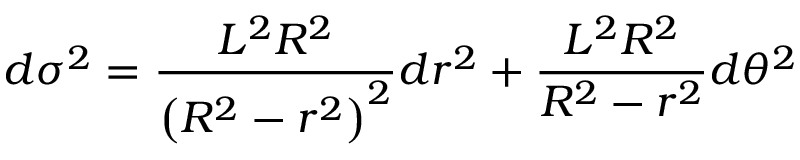<formula> <loc_0><loc_0><loc_500><loc_500>d \sigma ^ { 2 } = \frac { L ^ { 2 } R ^ { 2 } } { \left ( R ^ { 2 } - r ^ { 2 } \right ) ^ { 2 } } d r ^ { 2 } + \frac { L ^ { 2 } R ^ { 2 } } { R ^ { 2 } - r ^ { 2 } } d \theta ^ { 2 }</formula> 